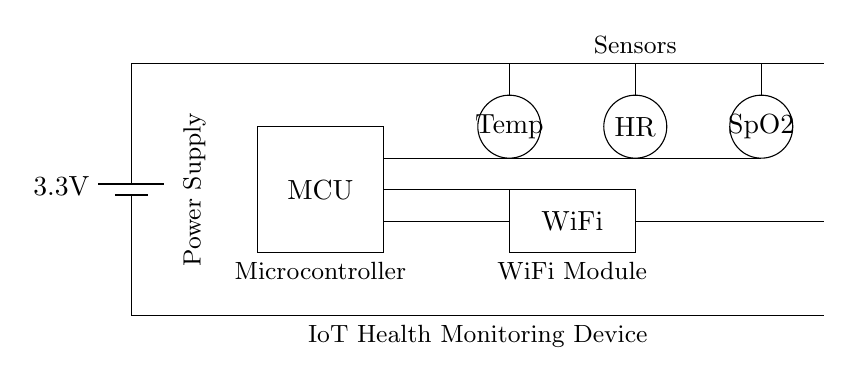What is the voltage of the power supply? The circuit shows a battery labeled as 3.3V, indicating the potential difference supplied to the circuit.
Answer: 3.3V What is the purpose of the MCU in this circuit? The microcontroller (MCU) is a critical component for processing data collected from the sensors and managing communication with the WiFi module.
Answer: Processing How many sensors are present in the circuit? The diagram displays three distinct sensors: one for temperature, one for heart rate, and one for blood oxygen levels.
Answer: Three Which component connects the sensors to the microcontroller? The sensors are connected to the microcontroller, with lines indicating data flow between them. This connection is necessary for the MCU to read sensor data.
Answer: Microcontroller What type of communication module is included in this IoT device? The diagram includes a WiFi module, which is explicitly labeled and allows for wireless data transmission, essential for IoT applications.
Answer: WiFi How are the sensors powered in the circuit? The sensors are powered through the connection utilized from the power supply, which leads to the top of the sensors. The power supply provides energy for the operation of these sensors.
Answer: Power supply 